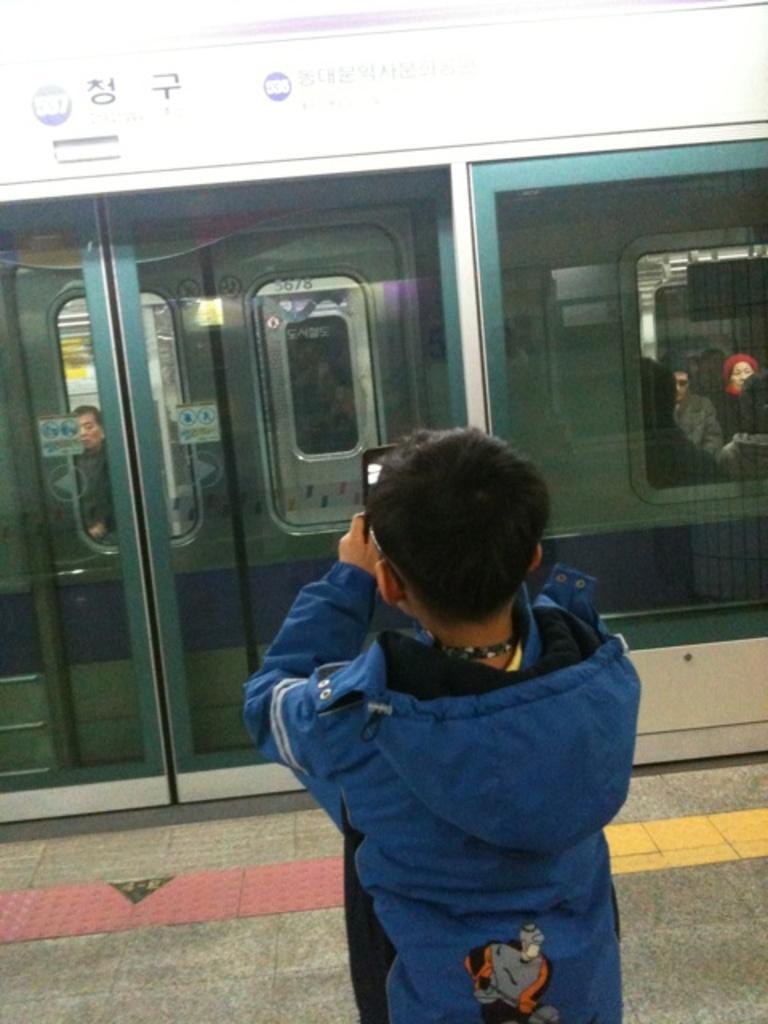How would you summarize this image in a sentence or two? In this image in the foreground there is one boy standing and he is holding a mobile, in front of them there is one train. In that train there are some people, and at the bottom there is a walkway. 